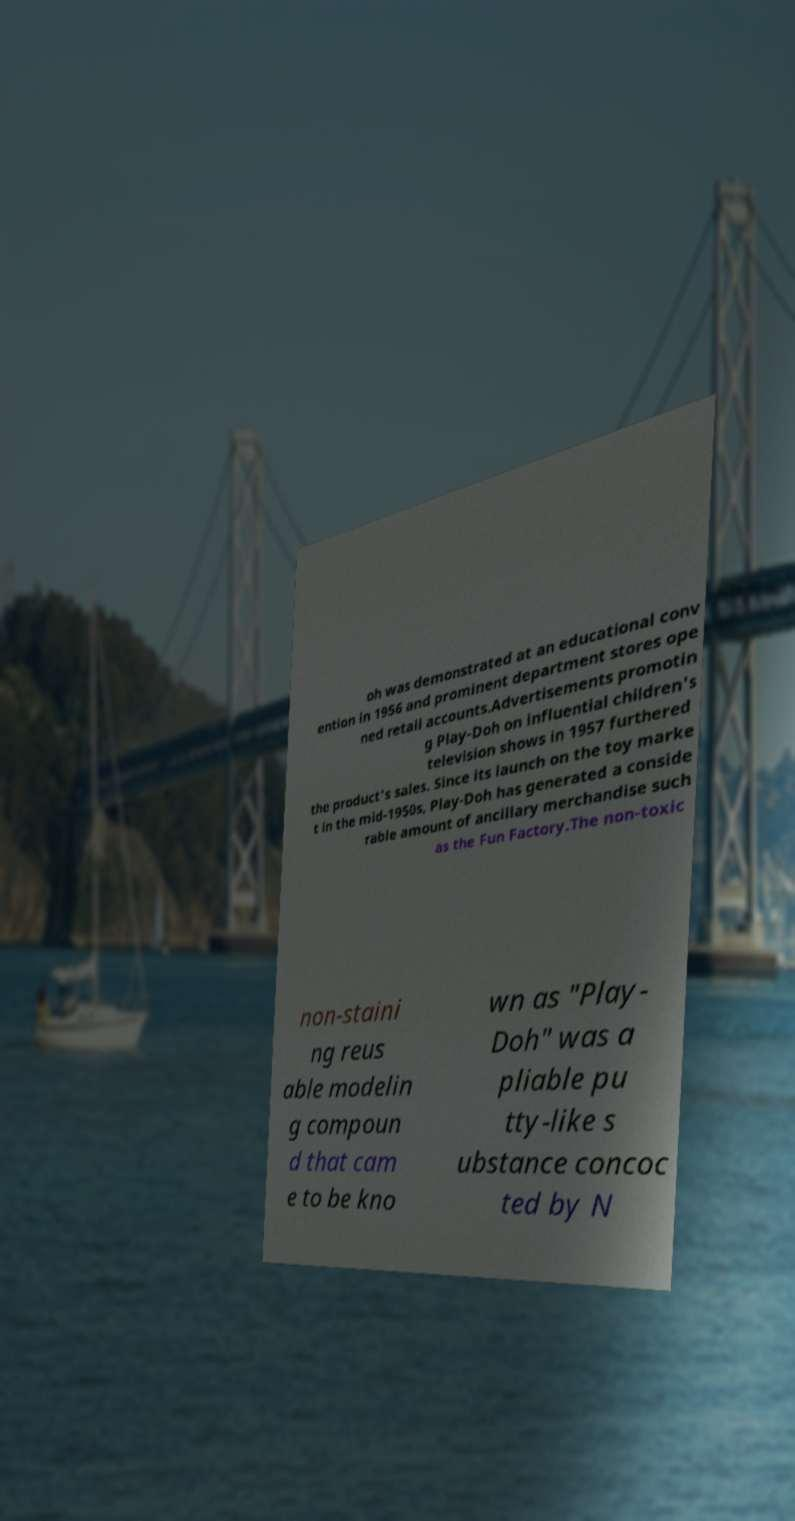Can you read and provide the text displayed in the image?This photo seems to have some interesting text. Can you extract and type it out for me? oh was demonstrated at an educational conv ention in 1956 and prominent department stores ope ned retail accounts.Advertisements promotin g Play-Doh on influential children's television shows in 1957 furthered the product's sales. Since its launch on the toy marke t in the mid-1950s, Play-Doh has generated a conside rable amount of ancillary merchandise such as the Fun Factory.The non-toxic non-staini ng reus able modelin g compoun d that cam e to be kno wn as "Play- Doh" was a pliable pu tty-like s ubstance concoc ted by N 